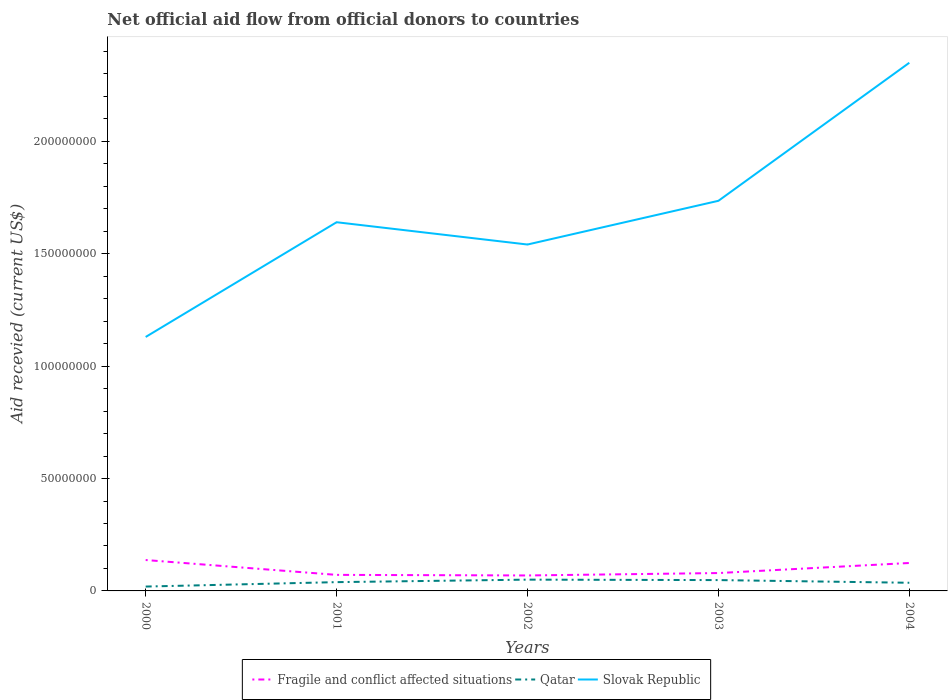How many different coloured lines are there?
Keep it short and to the point. 3. Does the line corresponding to Qatar intersect with the line corresponding to Slovak Republic?
Give a very brief answer. No. Is the number of lines equal to the number of legend labels?
Provide a succinct answer. Yes. Across all years, what is the maximum total aid received in Fragile and conflict affected situations?
Keep it short and to the point. 6.88e+06. What is the difference between the highest and the second highest total aid received in Qatar?
Your answer should be very brief. 3.08e+06. What is the difference between the highest and the lowest total aid received in Qatar?
Provide a succinct answer. 3. Is the total aid received in Fragile and conflict affected situations strictly greater than the total aid received in Qatar over the years?
Your response must be concise. No. How many lines are there?
Your answer should be compact. 3. What is the difference between two consecutive major ticks on the Y-axis?
Your response must be concise. 5.00e+07. Are the values on the major ticks of Y-axis written in scientific E-notation?
Your response must be concise. No. Does the graph contain any zero values?
Keep it short and to the point. No. Does the graph contain grids?
Your answer should be very brief. No. How many legend labels are there?
Ensure brevity in your answer.  3. How are the legend labels stacked?
Your answer should be compact. Horizontal. What is the title of the graph?
Offer a very short reply. Net official aid flow from official donors to countries. What is the label or title of the X-axis?
Offer a terse response. Years. What is the label or title of the Y-axis?
Give a very brief answer. Aid recevied (current US$). What is the Aid recevied (current US$) of Fragile and conflict affected situations in 2000?
Your response must be concise. 1.38e+07. What is the Aid recevied (current US$) of Qatar in 2000?
Provide a short and direct response. 1.94e+06. What is the Aid recevied (current US$) in Slovak Republic in 2000?
Offer a very short reply. 1.13e+08. What is the Aid recevied (current US$) of Fragile and conflict affected situations in 2001?
Keep it short and to the point. 7.14e+06. What is the Aid recevied (current US$) in Qatar in 2001?
Your answer should be compact. 3.91e+06. What is the Aid recevied (current US$) in Slovak Republic in 2001?
Your answer should be very brief. 1.64e+08. What is the Aid recevied (current US$) of Fragile and conflict affected situations in 2002?
Offer a very short reply. 6.88e+06. What is the Aid recevied (current US$) in Qatar in 2002?
Your answer should be very brief. 5.02e+06. What is the Aid recevied (current US$) of Slovak Republic in 2002?
Keep it short and to the point. 1.54e+08. What is the Aid recevied (current US$) of Fragile and conflict affected situations in 2003?
Provide a short and direct response. 7.95e+06. What is the Aid recevied (current US$) in Qatar in 2003?
Your answer should be very brief. 4.82e+06. What is the Aid recevied (current US$) of Slovak Republic in 2003?
Provide a short and direct response. 1.74e+08. What is the Aid recevied (current US$) of Fragile and conflict affected situations in 2004?
Your answer should be very brief. 1.24e+07. What is the Aid recevied (current US$) in Qatar in 2004?
Your answer should be very brief. 3.63e+06. What is the Aid recevied (current US$) in Slovak Republic in 2004?
Keep it short and to the point. 2.35e+08. Across all years, what is the maximum Aid recevied (current US$) of Fragile and conflict affected situations?
Your answer should be very brief. 1.38e+07. Across all years, what is the maximum Aid recevied (current US$) of Qatar?
Ensure brevity in your answer.  5.02e+06. Across all years, what is the maximum Aid recevied (current US$) in Slovak Republic?
Offer a very short reply. 2.35e+08. Across all years, what is the minimum Aid recevied (current US$) in Fragile and conflict affected situations?
Provide a succinct answer. 6.88e+06. Across all years, what is the minimum Aid recevied (current US$) in Qatar?
Keep it short and to the point. 1.94e+06. Across all years, what is the minimum Aid recevied (current US$) of Slovak Republic?
Offer a very short reply. 1.13e+08. What is the total Aid recevied (current US$) in Fragile and conflict affected situations in the graph?
Provide a succinct answer. 4.82e+07. What is the total Aid recevied (current US$) of Qatar in the graph?
Your answer should be compact. 1.93e+07. What is the total Aid recevied (current US$) in Slovak Republic in the graph?
Your answer should be compact. 8.40e+08. What is the difference between the Aid recevied (current US$) in Fragile and conflict affected situations in 2000 and that in 2001?
Your response must be concise. 6.61e+06. What is the difference between the Aid recevied (current US$) in Qatar in 2000 and that in 2001?
Provide a succinct answer. -1.97e+06. What is the difference between the Aid recevied (current US$) of Slovak Republic in 2000 and that in 2001?
Give a very brief answer. -5.10e+07. What is the difference between the Aid recevied (current US$) in Fragile and conflict affected situations in 2000 and that in 2002?
Your response must be concise. 6.87e+06. What is the difference between the Aid recevied (current US$) of Qatar in 2000 and that in 2002?
Keep it short and to the point. -3.08e+06. What is the difference between the Aid recevied (current US$) in Slovak Republic in 2000 and that in 2002?
Ensure brevity in your answer.  -4.11e+07. What is the difference between the Aid recevied (current US$) of Fragile and conflict affected situations in 2000 and that in 2003?
Provide a succinct answer. 5.80e+06. What is the difference between the Aid recevied (current US$) of Qatar in 2000 and that in 2003?
Provide a succinct answer. -2.88e+06. What is the difference between the Aid recevied (current US$) of Slovak Republic in 2000 and that in 2003?
Ensure brevity in your answer.  -6.06e+07. What is the difference between the Aid recevied (current US$) of Fragile and conflict affected situations in 2000 and that in 2004?
Ensure brevity in your answer.  1.32e+06. What is the difference between the Aid recevied (current US$) of Qatar in 2000 and that in 2004?
Your answer should be compact. -1.69e+06. What is the difference between the Aid recevied (current US$) of Slovak Republic in 2000 and that in 2004?
Your answer should be very brief. -1.22e+08. What is the difference between the Aid recevied (current US$) in Fragile and conflict affected situations in 2001 and that in 2002?
Provide a short and direct response. 2.60e+05. What is the difference between the Aid recevied (current US$) of Qatar in 2001 and that in 2002?
Your response must be concise. -1.11e+06. What is the difference between the Aid recevied (current US$) in Slovak Republic in 2001 and that in 2002?
Your response must be concise. 9.92e+06. What is the difference between the Aid recevied (current US$) of Fragile and conflict affected situations in 2001 and that in 2003?
Keep it short and to the point. -8.10e+05. What is the difference between the Aid recevied (current US$) in Qatar in 2001 and that in 2003?
Make the answer very short. -9.10e+05. What is the difference between the Aid recevied (current US$) in Slovak Republic in 2001 and that in 2003?
Provide a succinct answer. -9.53e+06. What is the difference between the Aid recevied (current US$) of Fragile and conflict affected situations in 2001 and that in 2004?
Ensure brevity in your answer.  -5.29e+06. What is the difference between the Aid recevied (current US$) of Qatar in 2001 and that in 2004?
Offer a very short reply. 2.80e+05. What is the difference between the Aid recevied (current US$) of Slovak Republic in 2001 and that in 2004?
Ensure brevity in your answer.  -7.10e+07. What is the difference between the Aid recevied (current US$) of Fragile and conflict affected situations in 2002 and that in 2003?
Your response must be concise. -1.07e+06. What is the difference between the Aid recevied (current US$) in Slovak Republic in 2002 and that in 2003?
Your response must be concise. -1.94e+07. What is the difference between the Aid recevied (current US$) of Fragile and conflict affected situations in 2002 and that in 2004?
Make the answer very short. -5.55e+06. What is the difference between the Aid recevied (current US$) in Qatar in 2002 and that in 2004?
Your answer should be compact. 1.39e+06. What is the difference between the Aid recevied (current US$) in Slovak Republic in 2002 and that in 2004?
Your response must be concise. -8.09e+07. What is the difference between the Aid recevied (current US$) in Fragile and conflict affected situations in 2003 and that in 2004?
Offer a very short reply. -4.48e+06. What is the difference between the Aid recevied (current US$) in Qatar in 2003 and that in 2004?
Your answer should be compact. 1.19e+06. What is the difference between the Aid recevied (current US$) of Slovak Republic in 2003 and that in 2004?
Your answer should be compact. -6.14e+07. What is the difference between the Aid recevied (current US$) of Fragile and conflict affected situations in 2000 and the Aid recevied (current US$) of Qatar in 2001?
Keep it short and to the point. 9.84e+06. What is the difference between the Aid recevied (current US$) in Fragile and conflict affected situations in 2000 and the Aid recevied (current US$) in Slovak Republic in 2001?
Ensure brevity in your answer.  -1.50e+08. What is the difference between the Aid recevied (current US$) in Qatar in 2000 and the Aid recevied (current US$) in Slovak Republic in 2001?
Provide a succinct answer. -1.62e+08. What is the difference between the Aid recevied (current US$) in Fragile and conflict affected situations in 2000 and the Aid recevied (current US$) in Qatar in 2002?
Keep it short and to the point. 8.73e+06. What is the difference between the Aid recevied (current US$) of Fragile and conflict affected situations in 2000 and the Aid recevied (current US$) of Slovak Republic in 2002?
Your answer should be compact. -1.40e+08. What is the difference between the Aid recevied (current US$) of Qatar in 2000 and the Aid recevied (current US$) of Slovak Republic in 2002?
Ensure brevity in your answer.  -1.52e+08. What is the difference between the Aid recevied (current US$) of Fragile and conflict affected situations in 2000 and the Aid recevied (current US$) of Qatar in 2003?
Make the answer very short. 8.93e+06. What is the difference between the Aid recevied (current US$) of Fragile and conflict affected situations in 2000 and the Aid recevied (current US$) of Slovak Republic in 2003?
Make the answer very short. -1.60e+08. What is the difference between the Aid recevied (current US$) in Qatar in 2000 and the Aid recevied (current US$) in Slovak Republic in 2003?
Your answer should be compact. -1.72e+08. What is the difference between the Aid recevied (current US$) in Fragile and conflict affected situations in 2000 and the Aid recevied (current US$) in Qatar in 2004?
Your answer should be compact. 1.01e+07. What is the difference between the Aid recevied (current US$) in Fragile and conflict affected situations in 2000 and the Aid recevied (current US$) in Slovak Republic in 2004?
Your answer should be compact. -2.21e+08. What is the difference between the Aid recevied (current US$) in Qatar in 2000 and the Aid recevied (current US$) in Slovak Republic in 2004?
Offer a terse response. -2.33e+08. What is the difference between the Aid recevied (current US$) of Fragile and conflict affected situations in 2001 and the Aid recevied (current US$) of Qatar in 2002?
Keep it short and to the point. 2.12e+06. What is the difference between the Aid recevied (current US$) of Fragile and conflict affected situations in 2001 and the Aid recevied (current US$) of Slovak Republic in 2002?
Offer a terse response. -1.47e+08. What is the difference between the Aid recevied (current US$) in Qatar in 2001 and the Aid recevied (current US$) in Slovak Republic in 2002?
Make the answer very short. -1.50e+08. What is the difference between the Aid recevied (current US$) of Fragile and conflict affected situations in 2001 and the Aid recevied (current US$) of Qatar in 2003?
Provide a succinct answer. 2.32e+06. What is the difference between the Aid recevied (current US$) of Fragile and conflict affected situations in 2001 and the Aid recevied (current US$) of Slovak Republic in 2003?
Make the answer very short. -1.66e+08. What is the difference between the Aid recevied (current US$) in Qatar in 2001 and the Aid recevied (current US$) in Slovak Republic in 2003?
Ensure brevity in your answer.  -1.70e+08. What is the difference between the Aid recevied (current US$) of Fragile and conflict affected situations in 2001 and the Aid recevied (current US$) of Qatar in 2004?
Keep it short and to the point. 3.51e+06. What is the difference between the Aid recevied (current US$) of Fragile and conflict affected situations in 2001 and the Aid recevied (current US$) of Slovak Republic in 2004?
Your answer should be very brief. -2.28e+08. What is the difference between the Aid recevied (current US$) in Qatar in 2001 and the Aid recevied (current US$) in Slovak Republic in 2004?
Make the answer very short. -2.31e+08. What is the difference between the Aid recevied (current US$) in Fragile and conflict affected situations in 2002 and the Aid recevied (current US$) in Qatar in 2003?
Your answer should be compact. 2.06e+06. What is the difference between the Aid recevied (current US$) in Fragile and conflict affected situations in 2002 and the Aid recevied (current US$) in Slovak Republic in 2003?
Provide a succinct answer. -1.67e+08. What is the difference between the Aid recevied (current US$) in Qatar in 2002 and the Aid recevied (current US$) in Slovak Republic in 2003?
Provide a succinct answer. -1.69e+08. What is the difference between the Aid recevied (current US$) in Fragile and conflict affected situations in 2002 and the Aid recevied (current US$) in Qatar in 2004?
Provide a short and direct response. 3.25e+06. What is the difference between the Aid recevied (current US$) of Fragile and conflict affected situations in 2002 and the Aid recevied (current US$) of Slovak Republic in 2004?
Ensure brevity in your answer.  -2.28e+08. What is the difference between the Aid recevied (current US$) of Qatar in 2002 and the Aid recevied (current US$) of Slovak Republic in 2004?
Ensure brevity in your answer.  -2.30e+08. What is the difference between the Aid recevied (current US$) of Fragile and conflict affected situations in 2003 and the Aid recevied (current US$) of Qatar in 2004?
Your answer should be compact. 4.32e+06. What is the difference between the Aid recevied (current US$) in Fragile and conflict affected situations in 2003 and the Aid recevied (current US$) in Slovak Republic in 2004?
Give a very brief answer. -2.27e+08. What is the difference between the Aid recevied (current US$) in Qatar in 2003 and the Aid recevied (current US$) in Slovak Republic in 2004?
Ensure brevity in your answer.  -2.30e+08. What is the average Aid recevied (current US$) of Fragile and conflict affected situations per year?
Offer a very short reply. 9.63e+06. What is the average Aid recevied (current US$) in Qatar per year?
Provide a succinct answer. 3.86e+06. What is the average Aid recevied (current US$) in Slovak Republic per year?
Make the answer very short. 1.68e+08. In the year 2000, what is the difference between the Aid recevied (current US$) in Fragile and conflict affected situations and Aid recevied (current US$) in Qatar?
Your answer should be compact. 1.18e+07. In the year 2000, what is the difference between the Aid recevied (current US$) of Fragile and conflict affected situations and Aid recevied (current US$) of Slovak Republic?
Give a very brief answer. -9.92e+07. In the year 2000, what is the difference between the Aid recevied (current US$) of Qatar and Aid recevied (current US$) of Slovak Republic?
Give a very brief answer. -1.11e+08. In the year 2001, what is the difference between the Aid recevied (current US$) in Fragile and conflict affected situations and Aid recevied (current US$) in Qatar?
Your response must be concise. 3.23e+06. In the year 2001, what is the difference between the Aid recevied (current US$) in Fragile and conflict affected situations and Aid recevied (current US$) in Slovak Republic?
Ensure brevity in your answer.  -1.57e+08. In the year 2001, what is the difference between the Aid recevied (current US$) of Qatar and Aid recevied (current US$) of Slovak Republic?
Give a very brief answer. -1.60e+08. In the year 2002, what is the difference between the Aid recevied (current US$) of Fragile and conflict affected situations and Aid recevied (current US$) of Qatar?
Offer a terse response. 1.86e+06. In the year 2002, what is the difference between the Aid recevied (current US$) of Fragile and conflict affected situations and Aid recevied (current US$) of Slovak Republic?
Offer a terse response. -1.47e+08. In the year 2002, what is the difference between the Aid recevied (current US$) in Qatar and Aid recevied (current US$) in Slovak Republic?
Ensure brevity in your answer.  -1.49e+08. In the year 2003, what is the difference between the Aid recevied (current US$) of Fragile and conflict affected situations and Aid recevied (current US$) of Qatar?
Provide a short and direct response. 3.13e+06. In the year 2003, what is the difference between the Aid recevied (current US$) in Fragile and conflict affected situations and Aid recevied (current US$) in Slovak Republic?
Your answer should be very brief. -1.66e+08. In the year 2003, what is the difference between the Aid recevied (current US$) of Qatar and Aid recevied (current US$) of Slovak Republic?
Keep it short and to the point. -1.69e+08. In the year 2004, what is the difference between the Aid recevied (current US$) in Fragile and conflict affected situations and Aid recevied (current US$) in Qatar?
Make the answer very short. 8.80e+06. In the year 2004, what is the difference between the Aid recevied (current US$) of Fragile and conflict affected situations and Aid recevied (current US$) of Slovak Republic?
Make the answer very short. -2.23e+08. In the year 2004, what is the difference between the Aid recevied (current US$) in Qatar and Aid recevied (current US$) in Slovak Republic?
Your response must be concise. -2.31e+08. What is the ratio of the Aid recevied (current US$) of Fragile and conflict affected situations in 2000 to that in 2001?
Offer a terse response. 1.93. What is the ratio of the Aid recevied (current US$) in Qatar in 2000 to that in 2001?
Ensure brevity in your answer.  0.5. What is the ratio of the Aid recevied (current US$) of Slovak Republic in 2000 to that in 2001?
Your answer should be very brief. 0.69. What is the ratio of the Aid recevied (current US$) in Fragile and conflict affected situations in 2000 to that in 2002?
Offer a very short reply. 2. What is the ratio of the Aid recevied (current US$) of Qatar in 2000 to that in 2002?
Your answer should be very brief. 0.39. What is the ratio of the Aid recevied (current US$) of Slovak Republic in 2000 to that in 2002?
Provide a succinct answer. 0.73. What is the ratio of the Aid recevied (current US$) of Fragile and conflict affected situations in 2000 to that in 2003?
Offer a very short reply. 1.73. What is the ratio of the Aid recevied (current US$) of Qatar in 2000 to that in 2003?
Ensure brevity in your answer.  0.4. What is the ratio of the Aid recevied (current US$) in Slovak Republic in 2000 to that in 2003?
Your answer should be compact. 0.65. What is the ratio of the Aid recevied (current US$) of Fragile and conflict affected situations in 2000 to that in 2004?
Ensure brevity in your answer.  1.11. What is the ratio of the Aid recevied (current US$) of Qatar in 2000 to that in 2004?
Provide a succinct answer. 0.53. What is the ratio of the Aid recevied (current US$) of Slovak Republic in 2000 to that in 2004?
Your answer should be compact. 0.48. What is the ratio of the Aid recevied (current US$) in Fragile and conflict affected situations in 2001 to that in 2002?
Ensure brevity in your answer.  1.04. What is the ratio of the Aid recevied (current US$) in Qatar in 2001 to that in 2002?
Provide a short and direct response. 0.78. What is the ratio of the Aid recevied (current US$) of Slovak Republic in 2001 to that in 2002?
Ensure brevity in your answer.  1.06. What is the ratio of the Aid recevied (current US$) in Fragile and conflict affected situations in 2001 to that in 2003?
Offer a terse response. 0.9. What is the ratio of the Aid recevied (current US$) in Qatar in 2001 to that in 2003?
Offer a terse response. 0.81. What is the ratio of the Aid recevied (current US$) in Slovak Republic in 2001 to that in 2003?
Your answer should be compact. 0.95. What is the ratio of the Aid recevied (current US$) of Fragile and conflict affected situations in 2001 to that in 2004?
Offer a terse response. 0.57. What is the ratio of the Aid recevied (current US$) of Qatar in 2001 to that in 2004?
Provide a short and direct response. 1.08. What is the ratio of the Aid recevied (current US$) in Slovak Republic in 2001 to that in 2004?
Your answer should be very brief. 0.7. What is the ratio of the Aid recevied (current US$) of Fragile and conflict affected situations in 2002 to that in 2003?
Offer a very short reply. 0.87. What is the ratio of the Aid recevied (current US$) of Qatar in 2002 to that in 2003?
Your answer should be compact. 1.04. What is the ratio of the Aid recevied (current US$) in Slovak Republic in 2002 to that in 2003?
Make the answer very short. 0.89. What is the ratio of the Aid recevied (current US$) in Fragile and conflict affected situations in 2002 to that in 2004?
Ensure brevity in your answer.  0.55. What is the ratio of the Aid recevied (current US$) in Qatar in 2002 to that in 2004?
Ensure brevity in your answer.  1.38. What is the ratio of the Aid recevied (current US$) in Slovak Republic in 2002 to that in 2004?
Provide a succinct answer. 0.66. What is the ratio of the Aid recevied (current US$) in Fragile and conflict affected situations in 2003 to that in 2004?
Provide a succinct answer. 0.64. What is the ratio of the Aid recevied (current US$) in Qatar in 2003 to that in 2004?
Your answer should be very brief. 1.33. What is the ratio of the Aid recevied (current US$) in Slovak Republic in 2003 to that in 2004?
Your answer should be very brief. 0.74. What is the difference between the highest and the second highest Aid recevied (current US$) in Fragile and conflict affected situations?
Your response must be concise. 1.32e+06. What is the difference between the highest and the second highest Aid recevied (current US$) in Slovak Republic?
Offer a very short reply. 6.14e+07. What is the difference between the highest and the lowest Aid recevied (current US$) of Fragile and conflict affected situations?
Your answer should be very brief. 6.87e+06. What is the difference between the highest and the lowest Aid recevied (current US$) in Qatar?
Provide a short and direct response. 3.08e+06. What is the difference between the highest and the lowest Aid recevied (current US$) in Slovak Republic?
Your answer should be very brief. 1.22e+08. 